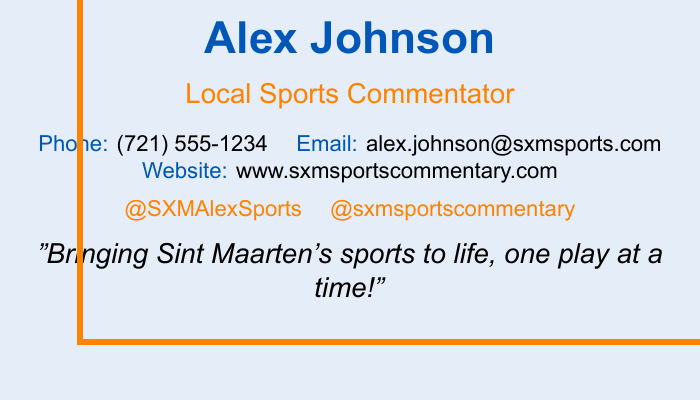What is the name of the commentator? The document presents the name "Alex Johnson" prominently.
Answer: Alex Johnson What is the commentator's title? Under the name, it states "Local Sports Commentator" as the title.
Answer: Local Sports Commentator What is the phone number listed on the card? The document explicitly includes the phone number as "(721) 555-1234".
Answer: (721) 555-1234 What is the email address of the commentator? The email is clearly stated as "alex.johnson@sxmsports.com".
Answer: alex.johnson@sxmsports.com What is the website mentioned? It provides the website link "www.sxmsportscommentary.com".
Answer: www.sxmsportscommentary.com What colors are used in the document? The colors used prominently include "sxmblue" and "sxmorange".
Answer: sxmblue, sxmorange What phrase captures the essence of the commentator's work? The document quotes "Bringing Sint Maarten's sports to life, one play at a time!" as the tagline.
Answer: Bringing Sint Maarten's sports to life, one play at a time! How many social media usernames are listed? Two social media handles are mentioned: "@SXMAlexSports" and "@sxmsportscommentary".
Answer: 2 What type of document is this? The overall layout and content indicate it is a business card.
Answer: Business card 